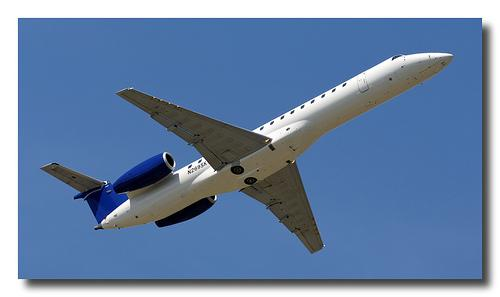Are the landing gear of the airplane up or down? The landing gear of the airplane is up. Examine the image and describe the environment in which the airplane is flying. The airplane is flying in a blue sky filled with white clouds at various positions and sizes. What is the sentiment evoked by the image? The image evokes a sense of adventure and travel as it captures an airplane flying through a clear sky. How many clouds can you count in the image? Nine white clouds can be counted in the blue sky. What can you determine about the quality of the image in terms of details and objects? The quality of the image seems high, as various details and objects such as the passenger jet, engine, windows, wings, tail wing, and clouds are clearly visible and annotated. Identify the primary object in the image and provide a brief description. The main object is a white and blue passenger jet with its landing gear up, flying in the blue sky with white clouds. In the image, what is the status of the airplane's door? The door is closed. What is the color and the pattern of the sky in the image? The sky is blue with white, fluffy clouds. Choose the correct description for the engine in the image: (a) Red engine with black trim (b) Blue engine with white trim (c) Green engine with yellow trim Blue engine with white trim What is the current state of the airplane's landing gear in the image? The landing gear is up. What is unique about the nose cone of the aircraft in the image? It is positioned at the front of the airplane and has a streamlined shape. What color is the passenger jet in the image? White and blue Provide a brief description of the cockpit windshield in the image. The windshield is small, located at the front of the airplane, and has a curve to its shape. How many clouds are there in the image? 9 Describe the components of the tail wing in the image. The tail wing is located at the rear of the aircraft, with white and blue coloring and a vertical stabilizer. Explain the relation between the airplane and the clouds in the image. The airplane is flying through a blue sky with white clouds. Where are the white clouds in the image located? The white clouds are scattered throughout the blue sky. Describe the color scheme and elements within the image. The image features a white and blue airplane, a blue sky, and white clouds. Identify the main components of the image: the airplane and the sky. The airplane is white and blue, and the sky is blue with white clouds. What is the position of the blue engine on the plane? It is positioned under the wing and towards the front of the aircraft. What can you observe about the wings on the aircraft in the image? The wings are large, extending from the center of the aircraft and have a streamlined design. In the image, are the clouds above or below the airplane? They are around the airplane. Describe the location and appearance of the windows on the aircraft in the image. They are located near the front of the aircraft with a rectangular shape and white trim. Select the correct option describing the sky in the image: (a) Clear blue sky (b) Blue sky with white clouds (c) Stormy sky with dark clouds Blue sky with white clouds Compare the size of the clouds with the size of the airplane in the image. The clouds are smaller than the airplane. Describe the scene involving the airplane and sky in the image. A white airplane and blue sky with white clouds scattered throughout. 